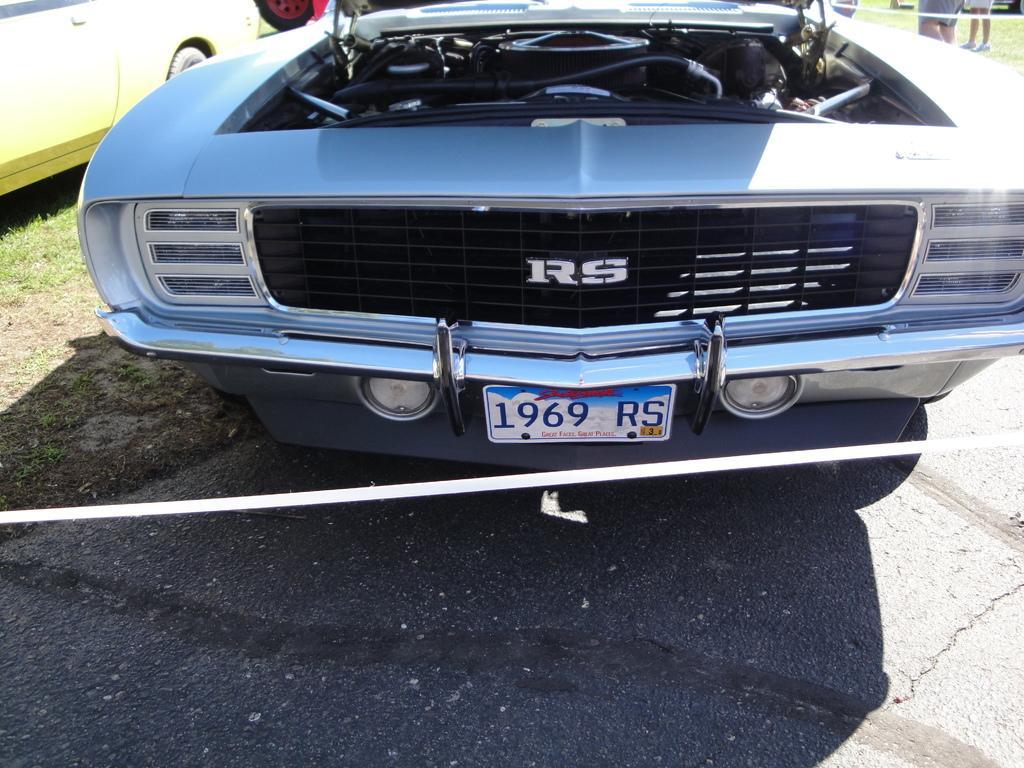Could you give a brief overview of what you see in this image? In this image I can see few vehicles. In the background I can see few people standing on the grass. 